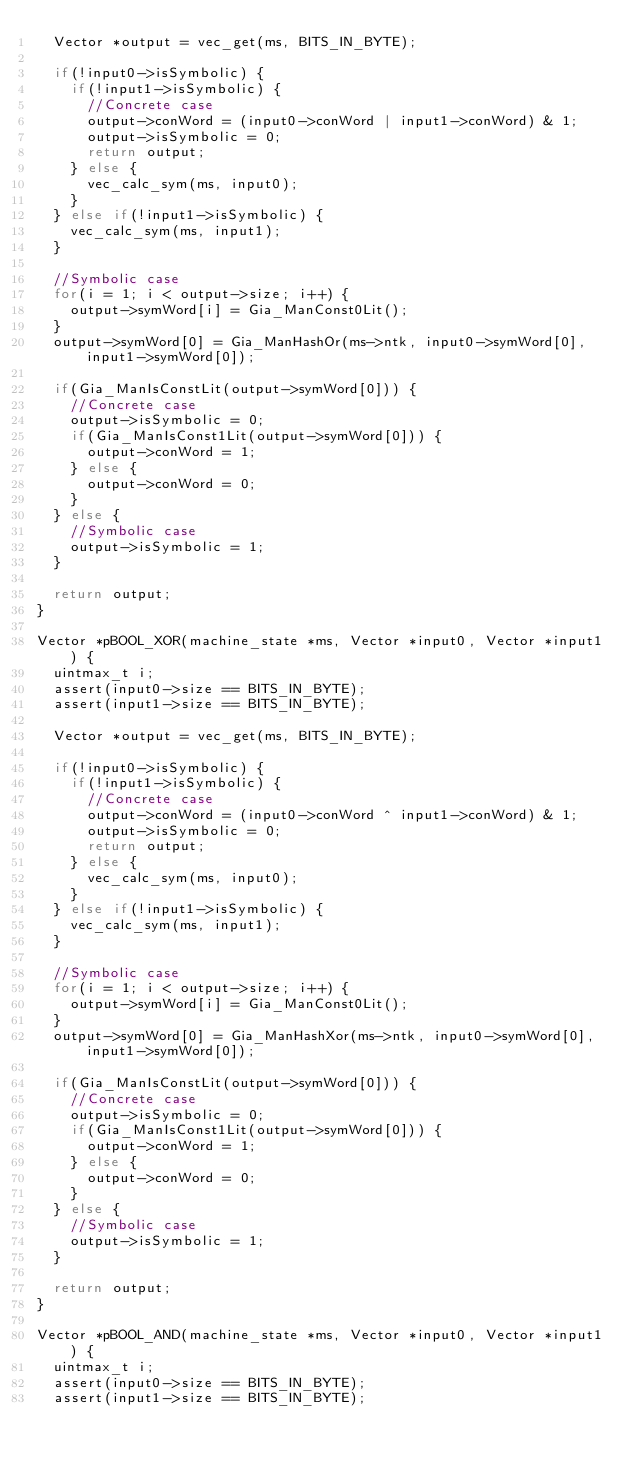<code> <loc_0><loc_0><loc_500><loc_500><_C_>  Vector *output = vec_get(ms, BITS_IN_BYTE);
  
  if(!input0->isSymbolic) {
    if(!input1->isSymbolic) {
      //Concrete case
      output->conWord = (input0->conWord | input1->conWord) & 1;
      output->isSymbolic = 0;
      return output;
    } else {
      vec_calc_sym(ms, input0);
    }
  } else if(!input1->isSymbolic) {
    vec_calc_sym(ms, input1);
  }
  
  //Symbolic case
  for(i = 1; i < output->size; i++) {
    output->symWord[i] = Gia_ManConst0Lit();
  }
  output->symWord[0] = Gia_ManHashOr(ms->ntk, input0->symWord[0], input1->symWord[0]);
  
  if(Gia_ManIsConstLit(output->symWord[0])) {
    //Concrete case
    output->isSymbolic = 0;
    if(Gia_ManIsConst1Lit(output->symWord[0])) {
      output->conWord = 1;
    } else {
      output->conWord = 0;
    }
  } else {
    //Symbolic case
    output->isSymbolic = 1;
  }
  
  return output;      
}

Vector *pBOOL_XOR(machine_state *ms, Vector *input0, Vector *input1) {
  uintmax_t i;
  assert(input0->size == BITS_IN_BYTE);
  assert(input1->size == BITS_IN_BYTE);
  
  Vector *output = vec_get(ms, BITS_IN_BYTE);
  
  if(!input0->isSymbolic) {
    if(!input1->isSymbolic) {
      //Concrete case
      output->conWord = (input0->conWord ^ input1->conWord) & 1;
      output->isSymbolic = 0;
      return output;
    } else {
      vec_calc_sym(ms, input0);
    }
  } else if(!input1->isSymbolic) {
    vec_calc_sym(ms, input1);
  }
  
  //Symbolic case
  for(i = 1; i < output->size; i++) {
    output->symWord[i] = Gia_ManConst0Lit();
  }
  output->symWord[0] = Gia_ManHashXor(ms->ntk, input0->symWord[0], input1->symWord[0]);
  
  if(Gia_ManIsConstLit(output->symWord[0])) {
    //Concrete case
    output->isSymbolic = 0;
    if(Gia_ManIsConst1Lit(output->symWord[0])) {
      output->conWord = 1;
    } else {
      output->conWord = 0;
    }
  } else {
    //Symbolic case
    output->isSymbolic = 1;
  }
  
  return output;      
}

Vector *pBOOL_AND(machine_state *ms, Vector *input0, Vector *input1) {
  uintmax_t i;
  assert(input0->size == BITS_IN_BYTE);
  assert(input1->size == BITS_IN_BYTE);
  </code> 